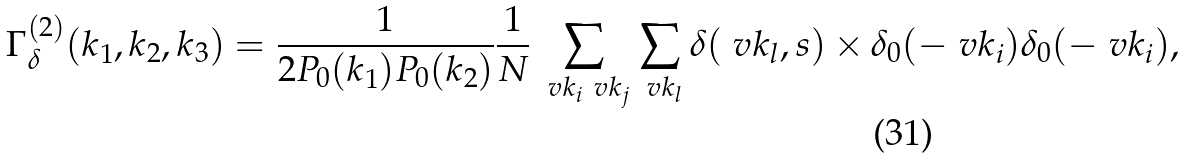Convert formula to latex. <formula><loc_0><loc_0><loc_500><loc_500>\Gamma ^ { ( 2 ) } _ { \delta } ( k _ { 1 } , k _ { 2 } , k _ { 3 } ) = \frac { 1 } { 2 P _ { 0 } ( k _ { 1 } ) P _ { 0 } ( k _ { 2 } ) } \frac { 1 } { N } \sum _ { \ v k _ { i } \ v k _ { j } } \sum _ { \ v k _ { l } } \delta ( \ v k _ { l } , s ) \times \delta _ { 0 } ( - \ v k _ { i } ) \delta _ { 0 } ( - \ v k _ { i } ) ,</formula> 